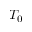<formula> <loc_0><loc_0><loc_500><loc_500>T _ { 0 }</formula> 